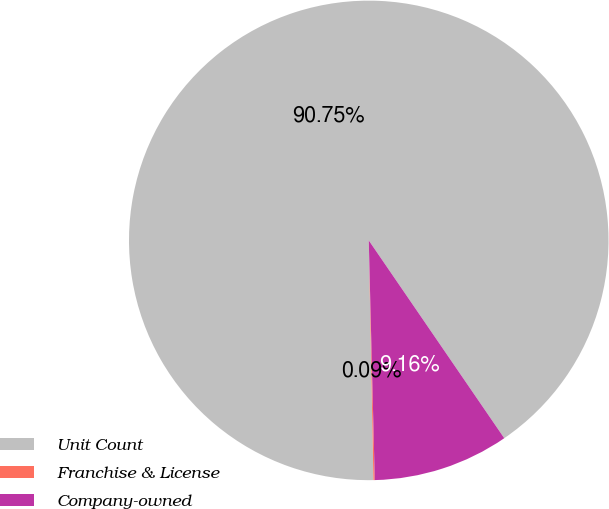Convert chart. <chart><loc_0><loc_0><loc_500><loc_500><pie_chart><fcel>Unit Count<fcel>Franchise & License<fcel>Company-owned<nl><fcel>90.75%<fcel>0.09%<fcel>9.16%<nl></chart> 